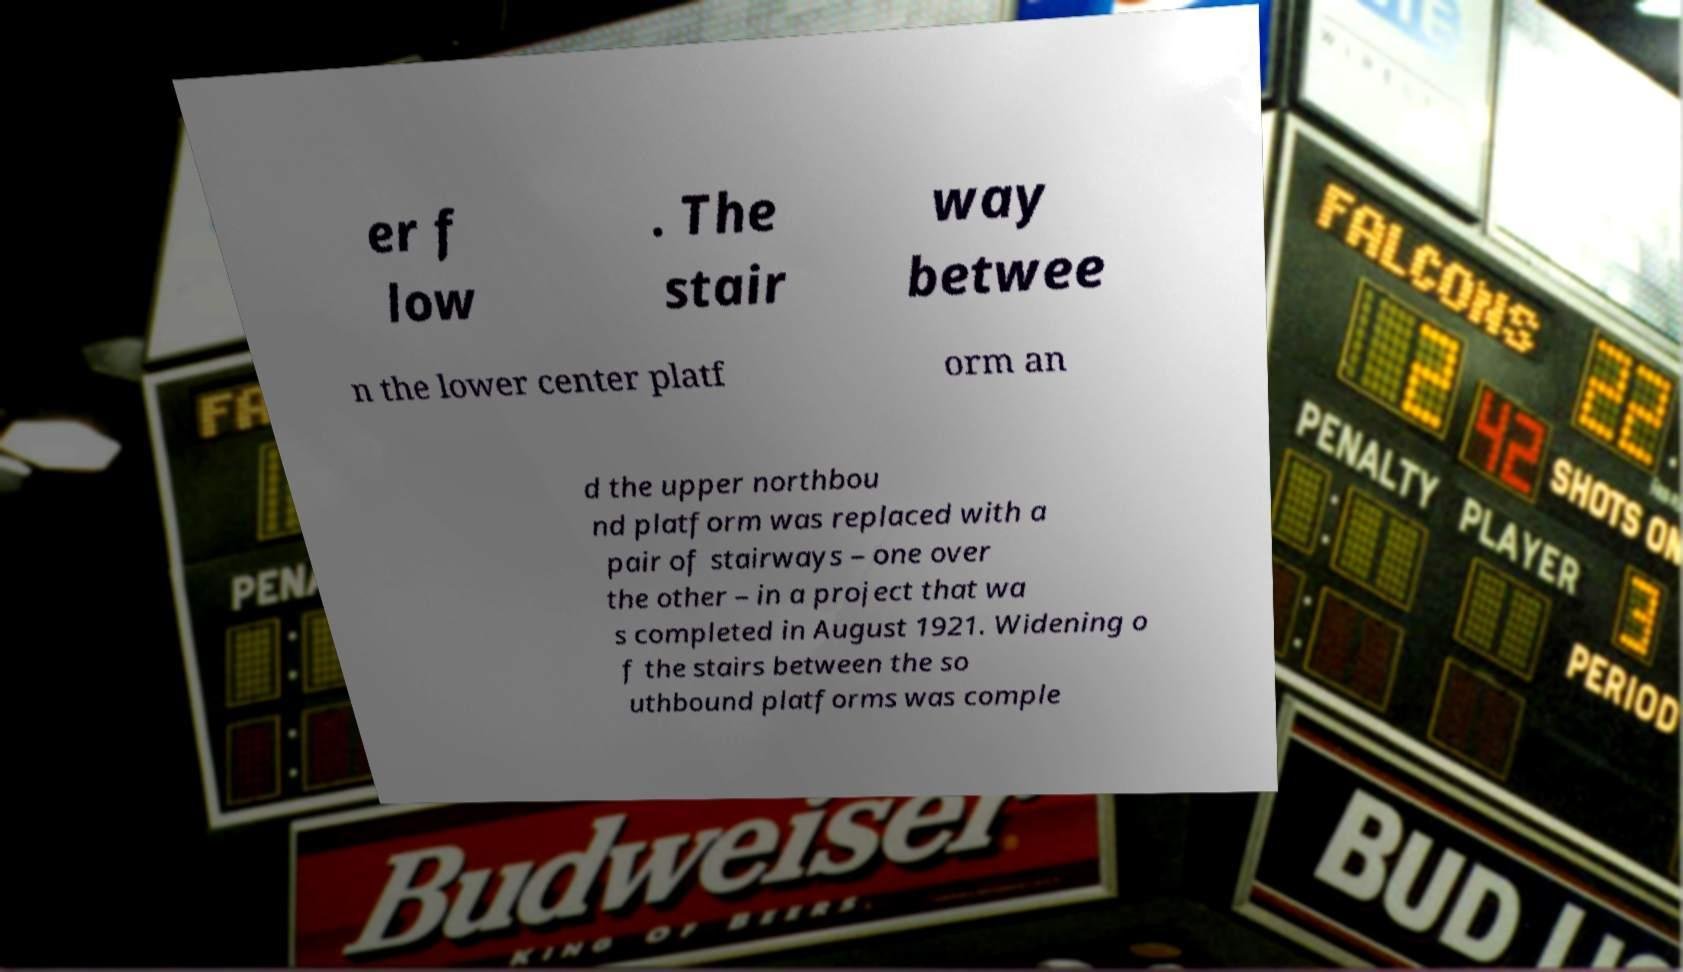Could you assist in decoding the text presented in this image and type it out clearly? er f low . The stair way betwee n the lower center platf orm an d the upper northbou nd platform was replaced with a pair of stairways – one over the other – in a project that wa s completed in August 1921. Widening o f the stairs between the so uthbound platforms was comple 